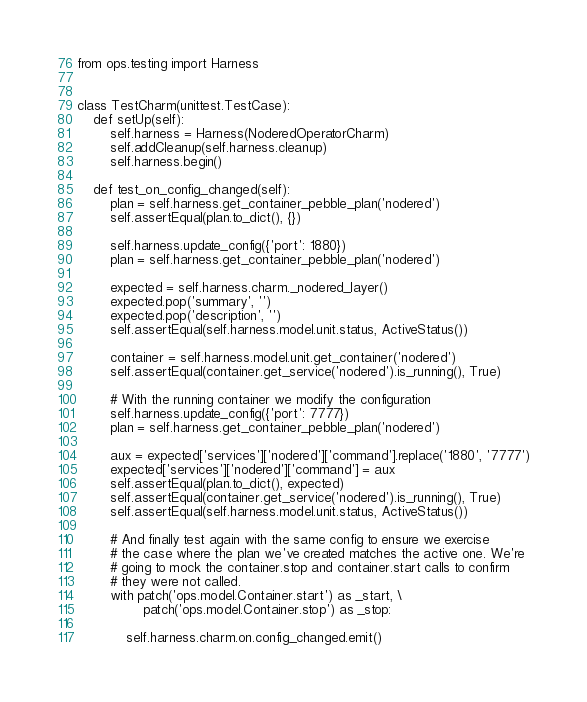<code> <loc_0><loc_0><loc_500><loc_500><_Python_>from ops.testing import Harness


class TestCharm(unittest.TestCase):
    def setUp(self):
        self.harness = Harness(NoderedOperatorCharm)
        self.addCleanup(self.harness.cleanup)
        self.harness.begin()

    def test_on_config_changed(self):
        plan = self.harness.get_container_pebble_plan('nodered')
        self.assertEqual(plan.to_dict(), {})

        self.harness.update_config({'port': 1880})
        plan = self.harness.get_container_pebble_plan('nodered')

        expected = self.harness.charm._nodered_layer()
        expected.pop('summary', '')
        expected.pop('description', '')
        self.assertEqual(self.harness.model.unit.status, ActiveStatus())

        container = self.harness.model.unit.get_container('nodered')
        self.assertEqual(container.get_service('nodered').is_running(), True)

        # With the running container we modify the configuration
        self.harness.update_config({'port': 7777})
        plan = self.harness.get_container_pebble_plan('nodered')

        aux = expected['services']['nodered']['command'].replace('1880', '7777')
        expected['services']['nodered']['command'] = aux
        self.assertEqual(plan.to_dict(), expected)
        self.assertEqual(container.get_service('nodered').is_running(), True)
        self.assertEqual(self.harness.model.unit.status, ActiveStatus())

        # And finally test again with the same config to ensure we exercise
        # the case where the plan we've created matches the active one. We're
        # going to mock the container.stop and container.start calls to confirm
        # they were not called.
        with patch('ops.model.Container.start') as _start, \
                patch('ops.model.Container.stop') as _stop:

            self.harness.charm.on.config_changed.emit()</code> 